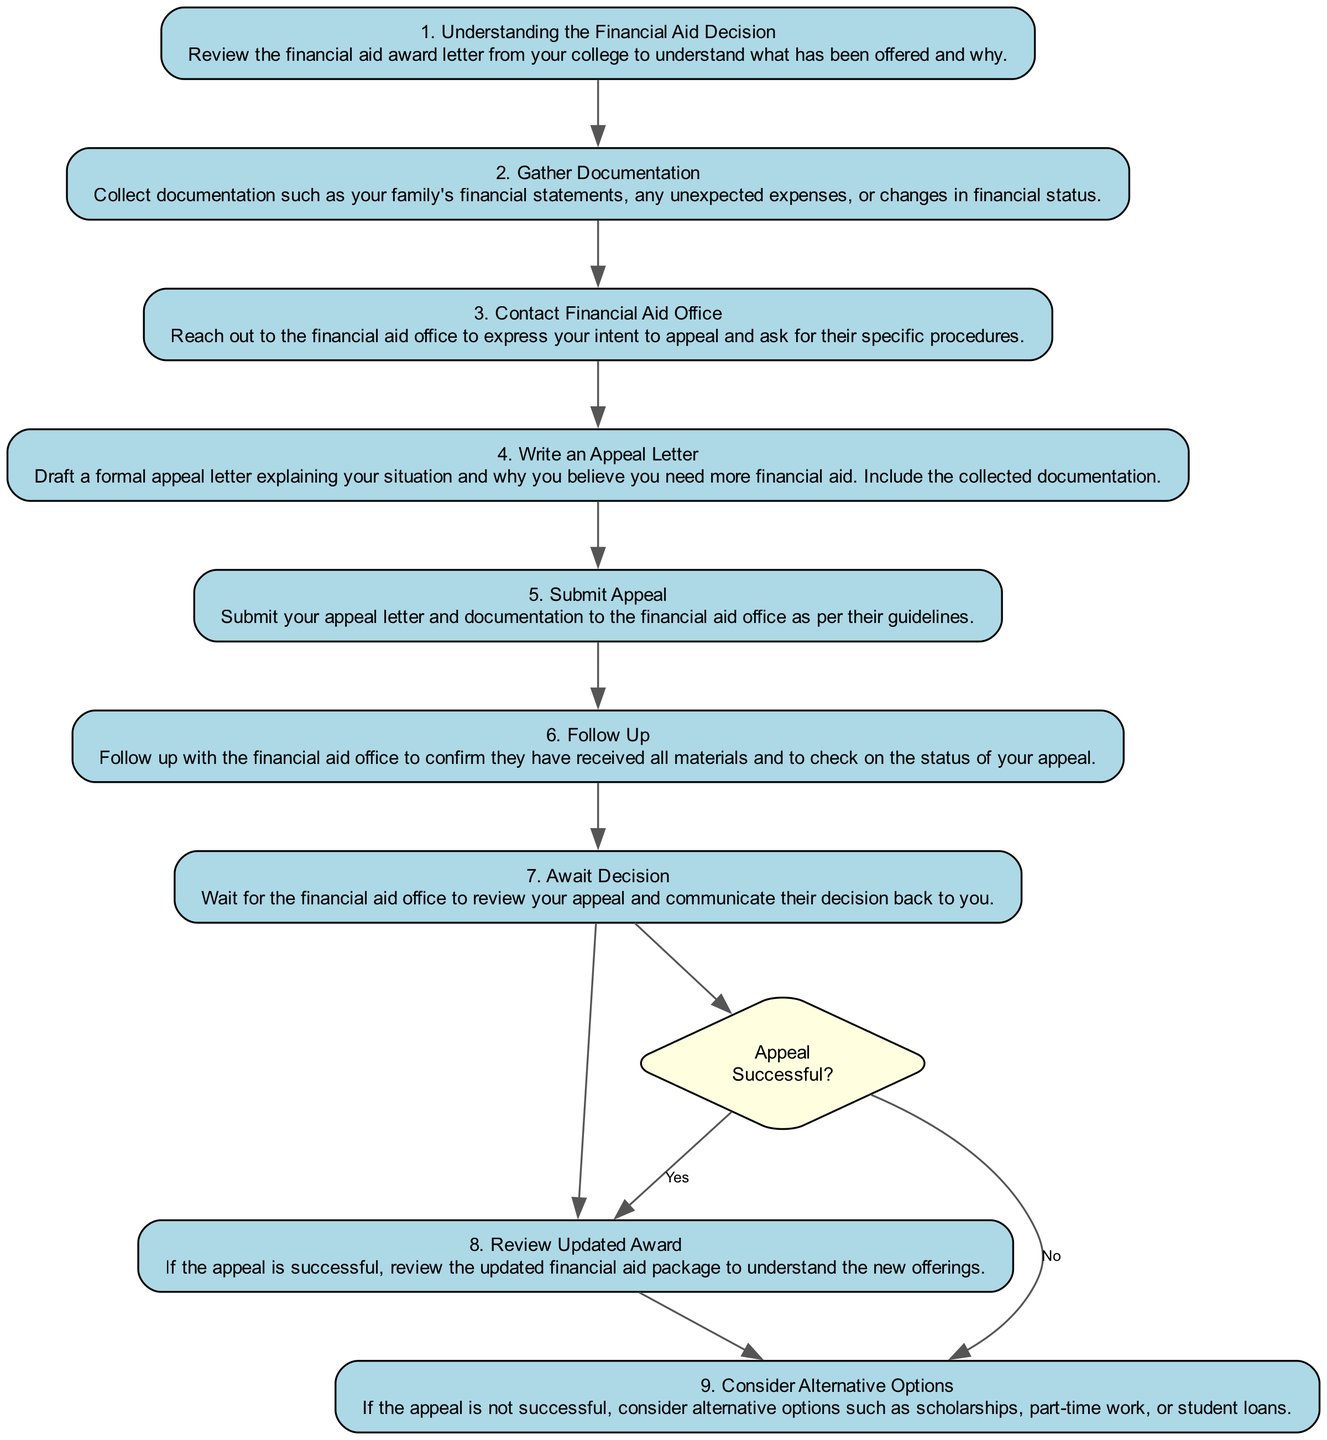What is the first step in the appeal process? The diagram starts with step 1, which is titled "Understanding the Financial Aid Decision" and describes the action of reviewing the financial aid award letter.
Answer: Understanding the Financial Aid Decision How many steps are there in the appeal process? The diagram lists 9 distinct steps, which are outlined sequentially from the beginning to the end of the process.
Answer: 9 What document should you gather in step 2? Step 2 specifies gathering documentation, particularly mentioning family financial statements and unexpected expenses.
Answer: Documentation What do you need to do in step 3? In step 3, you need to contact the financial aid office to express your intent to appeal and ask for their specific procedures.
Answer: Contact Financial Aid Office What happens if your appeal is successful? If your appeal is successful, you can move to step 8, which involves reviewing the updated financial aid package to understand the new offerings.
Answer: Review Updated Award What comes after writing an appeal letter? After writing an appeal letter in step 4, the next action to take is to submit that letter in step 5 according to the financial aid office's guidelines.
Answer: Submit Appeal What is the last step if the appeal is not successful? If the appeal is not granted, the last step involves considering alternative options such as scholarships, part-time work, or student loans, which is outlined in step 9.
Answer: Consider Alternative Options How do you confirm the status of your appeal? In step 6, you follow up with the financial aid office to confirm that they have received all materials and check on the status of your appeal.
Answer: Follow Up What type of node represents the decision point after waiting for a decision? The decision point after awaiting the decision is represented by a diamond-shaped node labeled "Appeal Successful?" in the diagram.
Answer: Diamond 